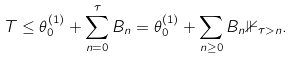<formula> <loc_0><loc_0><loc_500><loc_500>T \leq \theta ^ { ( 1 ) } _ { 0 } + \sum _ { n = 0 } ^ { \tau } B _ { n } = \theta ^ { ( 1 ) } _ { 0 } + \sum _ { n \geq 0 } B _ { n } \mathbb { 1 } _ { \tau > n } .</formula> 